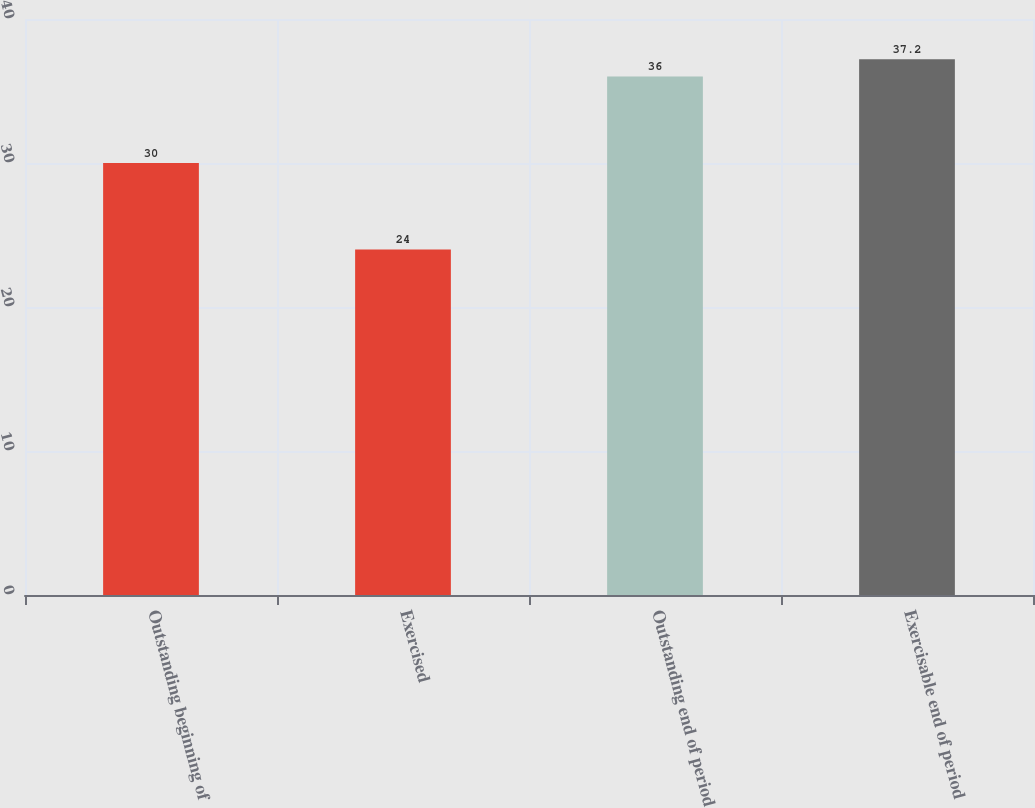Convert chart to OTSL. <chart><loc_0><loc_0><loc_500><loc_500><bar_chart><fcel>Outstanding beginning of<fcel>Exercised<fcel>Outstanding end of period<fcel>Exercisable end of period<nl><fcel>30<fcel>24<fcel>36<fcel>37.2<nl></chart> 